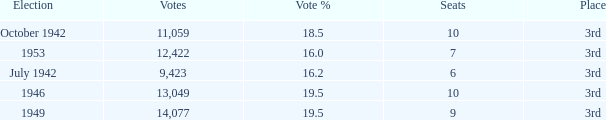Name the most vote % with election of 1946 19.5. 